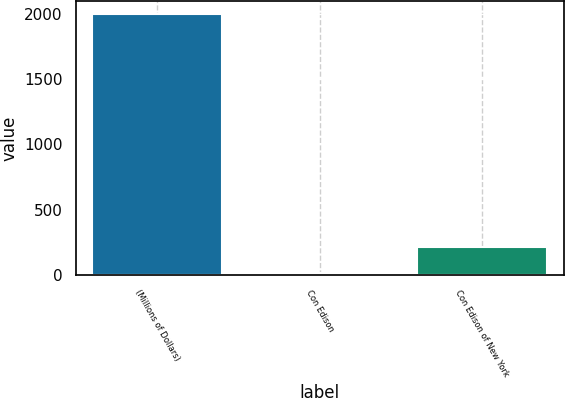Convert chart to OTSL. <chart><loc_0><loc_0><loc_500><loc_500><bar_chart><fcel>(Millions of Dollars)<fcel>Con Edison<fcel>Con Edison of New York<nl><fcel>2001<fcel>14<fcel>212.7<nl></chart> 